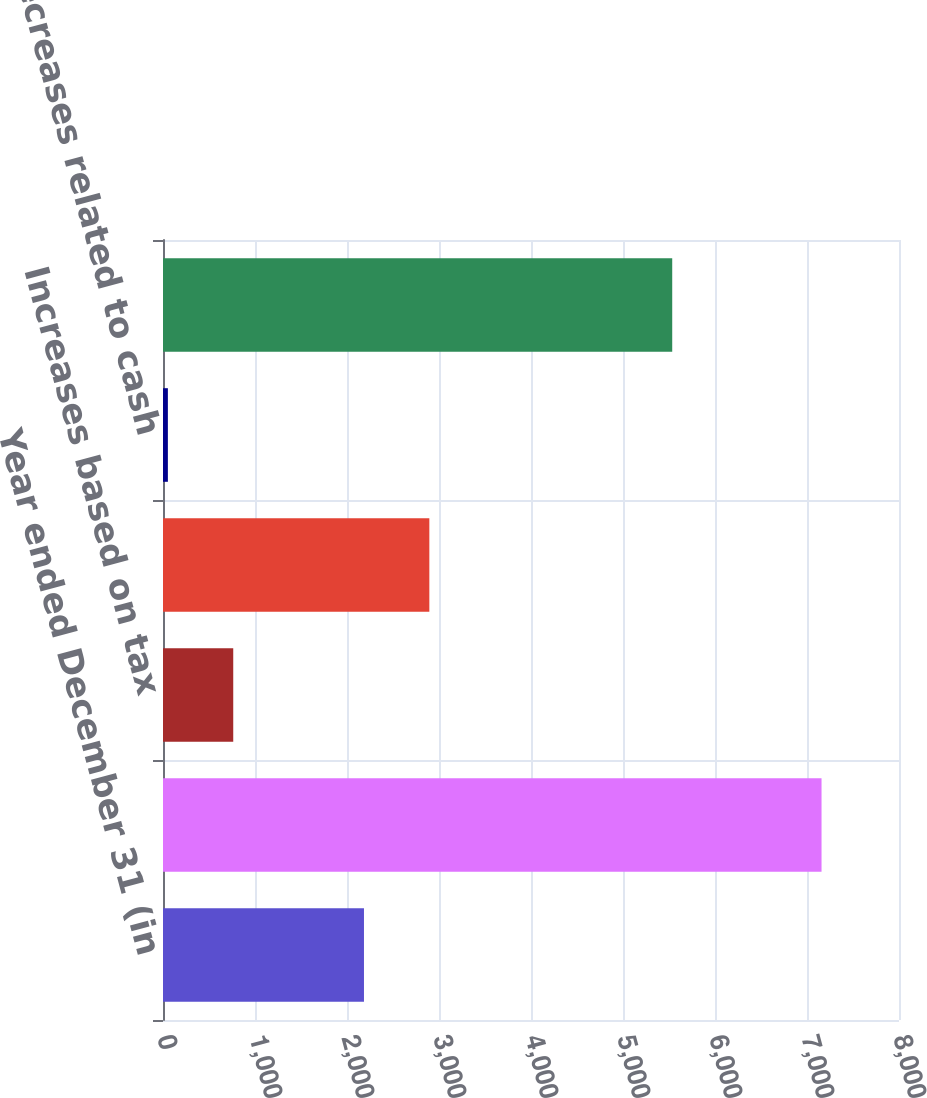Convert chart. <chart><loc_0><loc_0><loc_500><loc_500><bar_chart><fcel>Year ended December 31 (in<fcel>Balance at January 1<fcel>Increases based on tax<fcel>Decreases based on tax<fcel>Decreases related to cash<fcel>Balance at December 31<nl><fcel>2184.5<fcel>7158<fcel>763.5<fcel>2895<fcel>53<fcel>5535<nl></chart> 